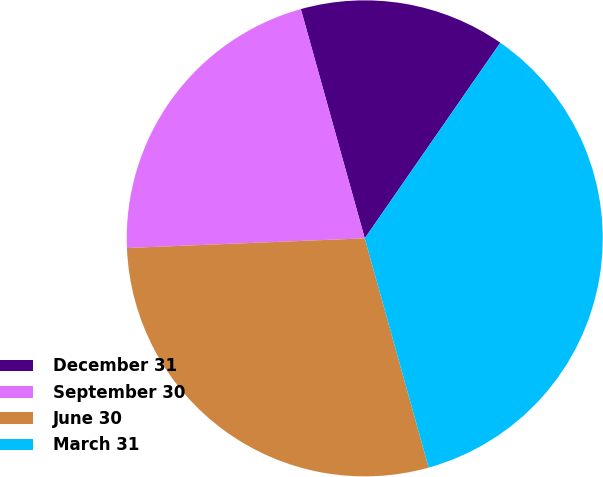<chart> <loc_0><loc_0><loc_500><loc_500><pie_chart><fcel>December 31<fcel>September 30<fcel>June 30<fcel>March 31<nl><fcel>13.97%<fcel>21.32%<fcel>28.68%<fcel>36.03%<nl></chart> 